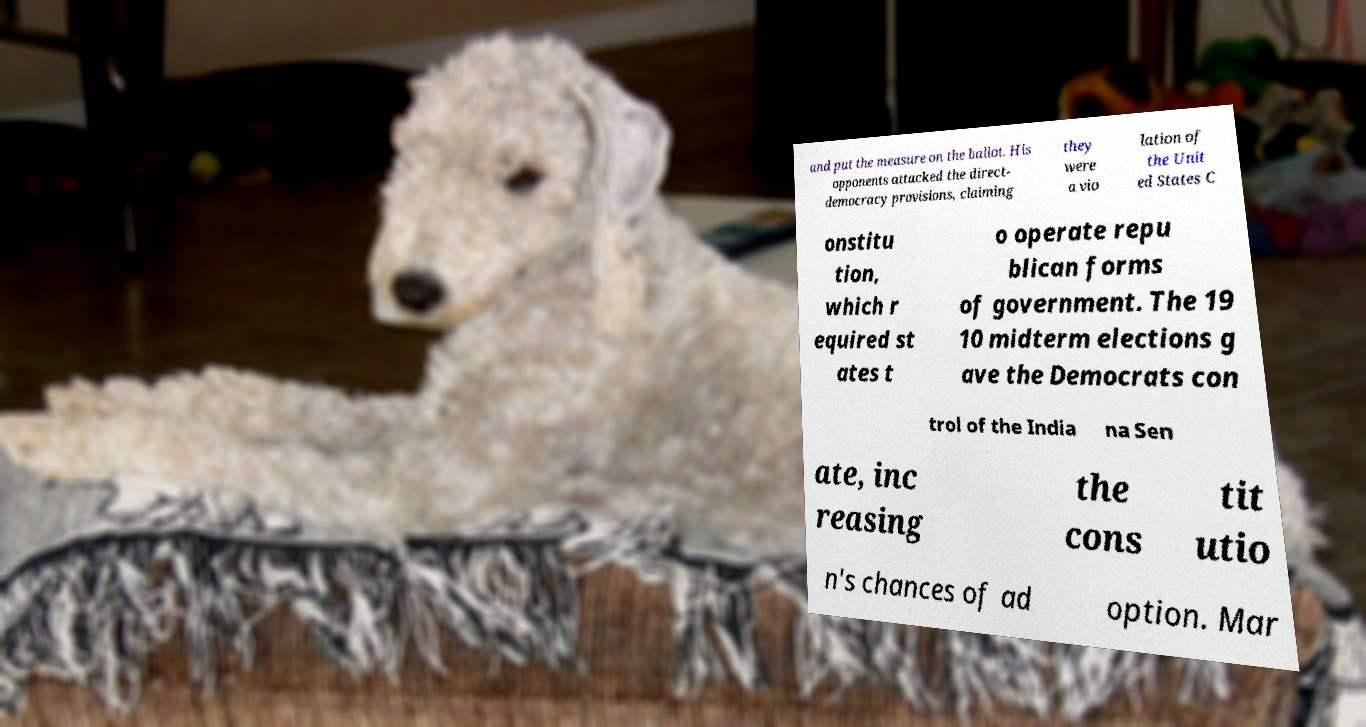I need the written content from this picture converted into text. Can you do that? and put the measure on the ballot. His opponents attacked the direct- democracy provisions, claiming they were a vio lation of the Unit ed States C onstitu tion, which r equired st ates t o operate repu blican forms of government. The 19 10 midterm elections g ave the Democrats con trol of the India na Sen ate, inc reasing the cons tit utio n's chances of ad option. Mar 